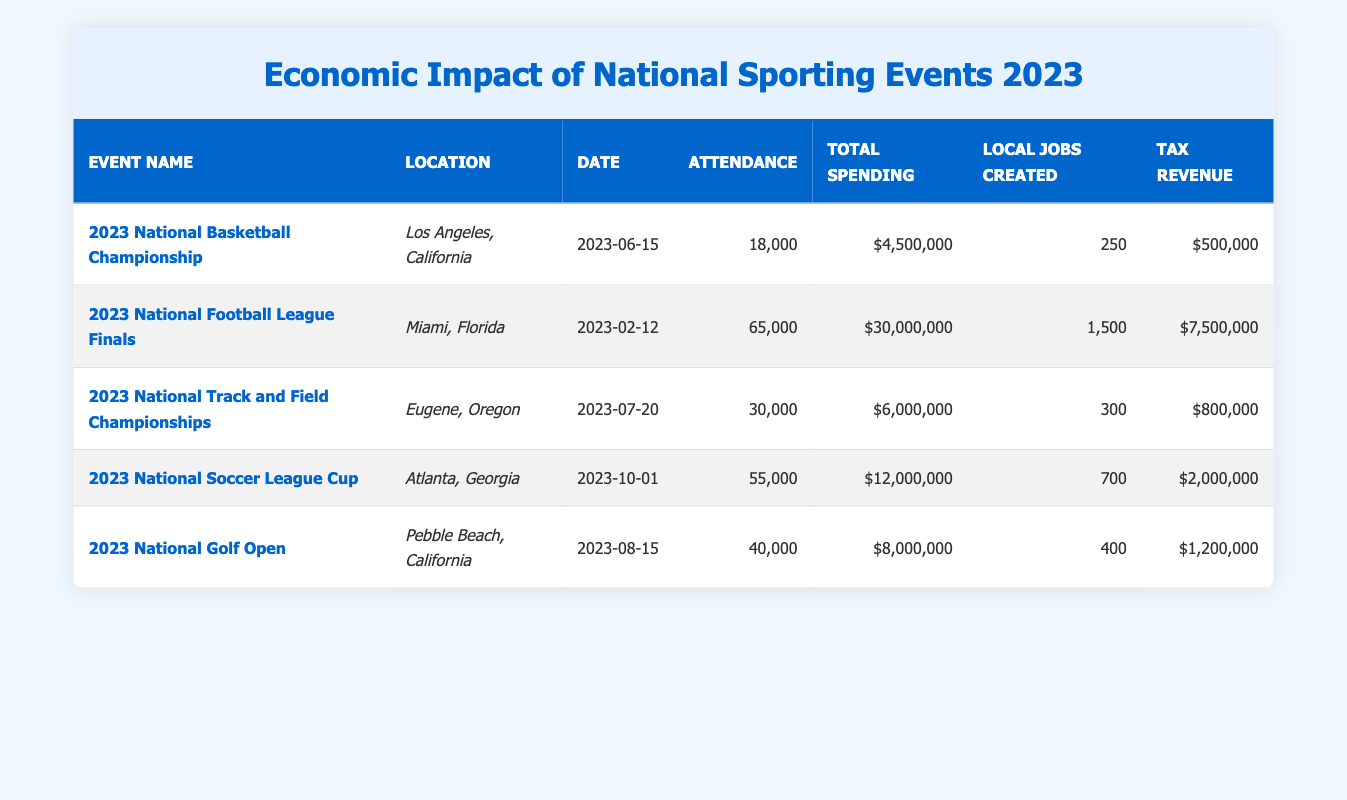What is the attendance for the 2023 National Basketball Championship? The attendance is explicitly mentioned in the row of the event named "2023 National Basketball Championship" as 18,000.
Answer: 18,000 Which event generated the highest total spending? To find the event with the highest total spending, we compare the "Total Spending" values for each event. The "2023 National Football League Finals" has the highest total spending of $30,000,000.
Answer: 2023 National Football League Finals How many total local jobs were created across all events? By adding the "Local Jobs Created" values from each event, we calculate: 250 + 1500 + 300 + 700 + 400 = 3150. Thus, the total number of local jobs created is 3,150.
Answer: 3150 Is the tax revenue from the 2023 National Track and Field Championships greater than $700,000? The tax revenue for the event is listed as $800,000. Since $800,000 is greater than $700,000, the statement is true.
Answer: Yes What is the average attendance across all events? The total attendance can be calculated by adding each attendance figure: 18,000 + 65,000 + 30,000 + 55,000 + 40,000 = 208,000. There are 5 events, so the average attendance is 208,000 / 5 = 41,600.
Answer: 41,600 Which event took place in July? The row for the event shows "2023 National Track and Field Championships" occurred on July 20, making it the only event in that month.
Answer: 2023 National Track and Field Championships How much tax revenue was generated from the 2023 National Soccer League Cup? Looking at the corresponding row for the event "2023 National Soccer League Cup," the tax revenue is listed as $2,000,000.
Answer: $2,000,000 How many more local jobs were created in the 2023 National Football League Finals than in the 2023 National Golf Open? The local jobs created for the NFL Finals is 1,500, and for the Golf Open, it is 400. So, the difference is 1,500 - 400 = 1,100.
Answer: 1,100 What location had the event with the lowest attendance? Comparing the attendance figures, the "2023 National Basketball Championship" had the lowest attendance of 18,000, which took place in Los Angeles, California.
Answer: Los Angeles, California 